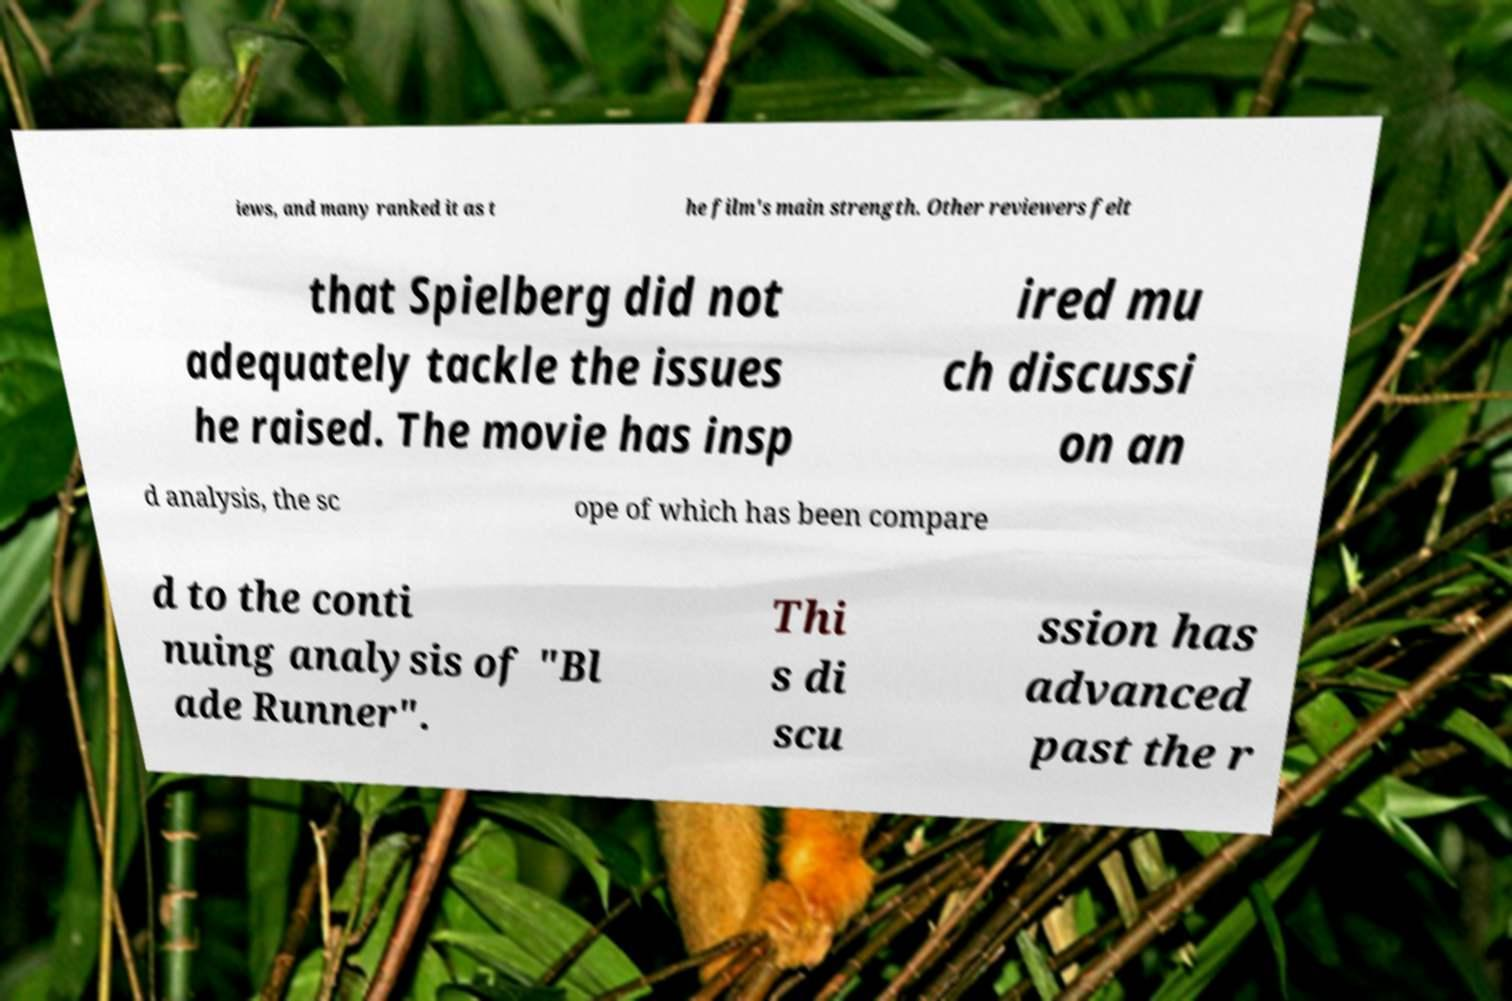For documentation purposes, I need the text within this image transcribed. Could you provide that? iews, and many ranked it as t he film's main strength. Other reviewers felt that Spielberg did not adequately tackle the issues he raised. The movie has insp ired mu ch discussi on an d analysis, the sc ope of which has been compare d to the conti nuing analysis of "Bl ade Runner". Thi s di scu ssion has advanced past the r 